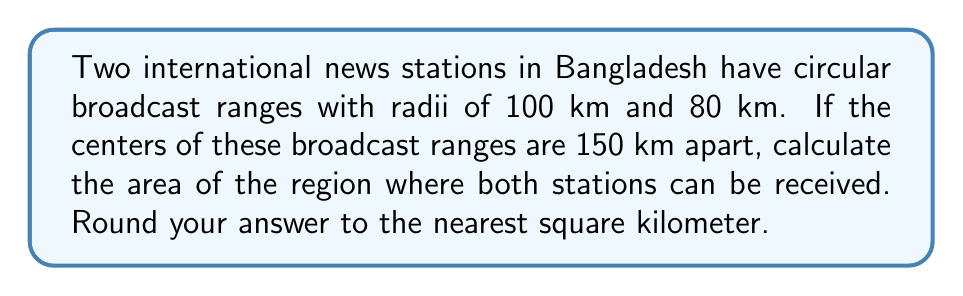Solve this math problem. Let's approach this step-by-step:

1) This is a problem of finding the area of intersection of two circles. We'll use the formula for the area of intersection:

   $$A = r_1^2 \arccos(\frac{d^2 + r_1^2 - r_2^2}{2dr_1}) + r_2^2 \arccos(\frac{d^2 + r_2^2 - r_1^2}{2dr_2}) - \frac{1}{2}\sqrt{(-d+r_1+r_2)(d+r_1-r_2)(d-r_1+r_2)(d+r_1+r_2)}$$

   Where $r_1$ and $r_2$ are the radii of the circles, and $d$ is the distance between their centers.

2) Given:
   $r_1 = 100$ km
   $r_2 = 80$ km
   $d = 150$ km

3) Let's substitute these values into our formula:

   $$A = 100^2 \arccos(\frac{150^2 + 100^2 - 80^2}{2 \cdot 150 \cdot 100}) + 80^2 \arccos(\frac{150^2 + 80^2 - 100^2}{2 \cdot 150 \cdot 80}) - \frac{1}{2}\sqrt{(-150+100+80)(150+100-80)(150-100+80)(150+100+80)}$$

4) Simplify:

   $$A = 10000 \arccos(0.7583) + 6400 \arccos(0.8167) - \frac{1}{2}\sqrt{(30)(170)(130)(330)}$$

5) Calculate:

   $$A = 10000 \cdot 0.7211 + 6400 \cdot 0.6069 - \frac{1}{2} \cdot 9165.15$$

   $$A = 7211 + 3884.16 - 4582.58$$

   $$A = 6512.58$$

6) Rounding to the nearest square kilometer:

   $$A \approx 6513 \text{ km}^2$$

[asy]
import geometry;

// Define the circles
pair center1 = (0,0);
pair center2 = (150,0);
real r1 = 100;
real r2 = 80;

// Draw the circles
draw(circle(center1, r1), rgb(0,0,1));
draw(circle(center2, r2), rgb(1,0,0));

// Label the centers and radii
label("100 km", (50,0), N);
label("80 km", (225,0), N);
label("150 km", (75,0), S);

// Draw the overlap region
path p = intersectionpoint(circle(center1,r1), circle(center2,r2))--arc(center2,r2,180,360)--arc(center1,r1,0,180)--cycle;
fill(p, rgb(0.5,0,0.5,0.2));

// Set the view
size(200);
[/asy]
Answer: 6513 km² 